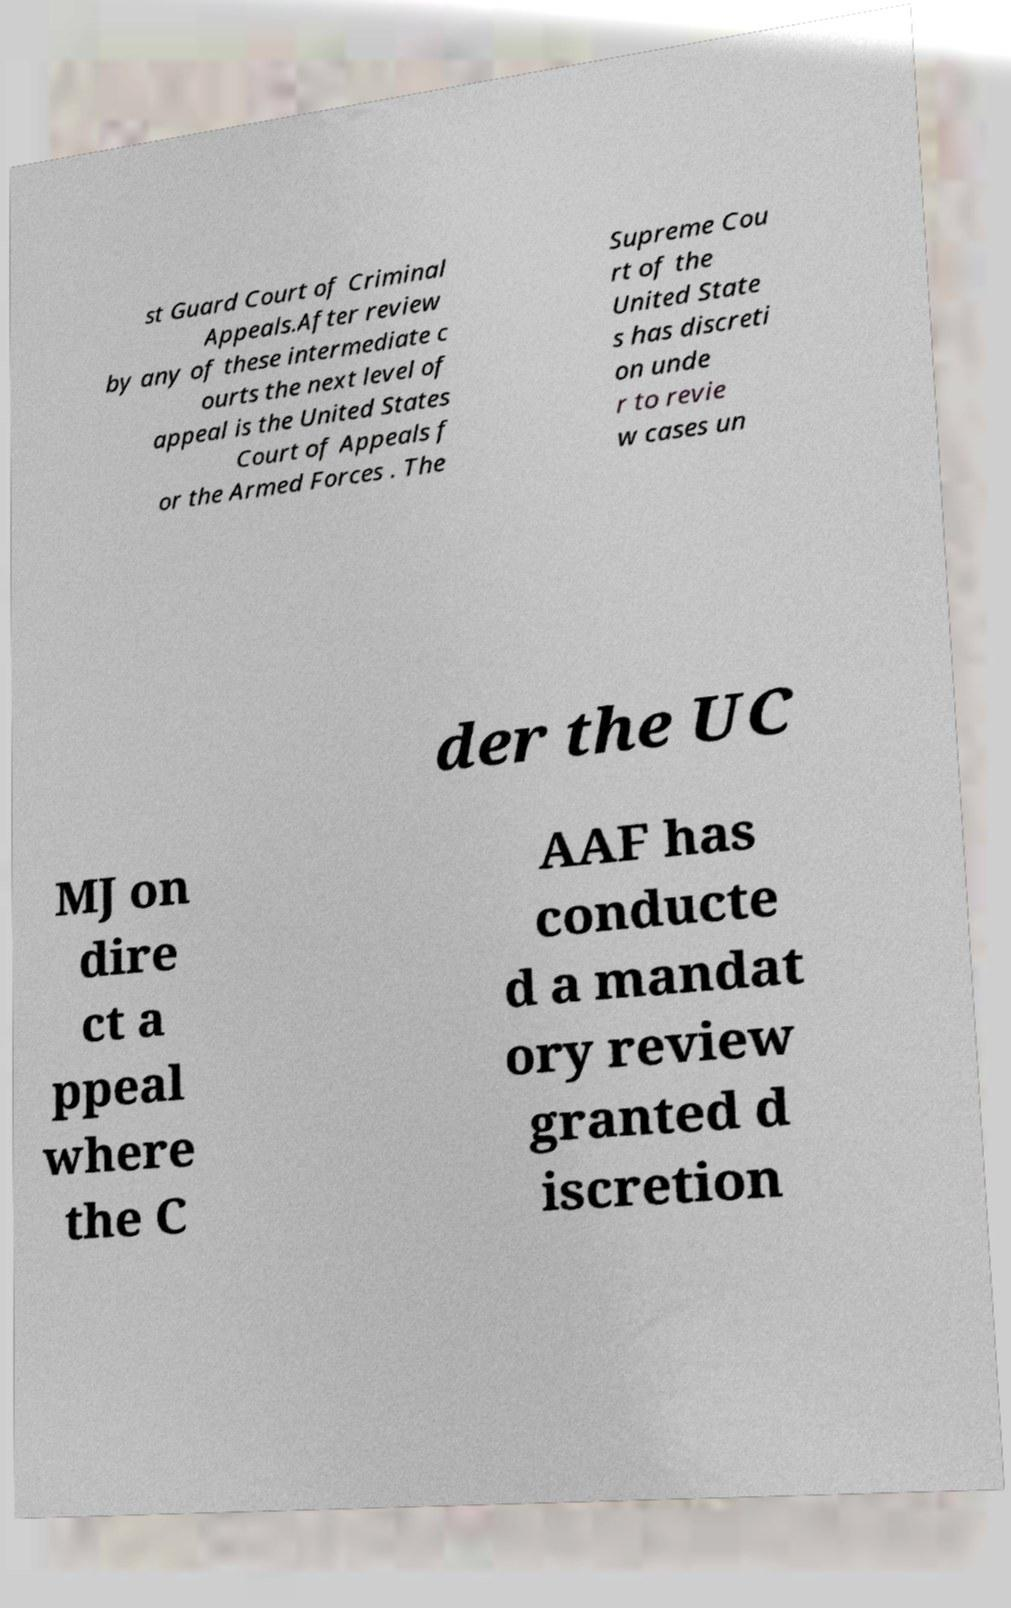Could you assist in decoding the text presented in this image and type it out clearly? st Guard Court of Criminal Appeals.After review by any of these intermediate c ourts the next level of appeal is the United States Court of Appeals f or the Armed Forces . The Supreme Cou rt of the United State s has discreti on unde r to revie w cases un der the UC MJ on dire ct a ppeal where the C AAF has conducte d a mandat ory review granted d iscretion 